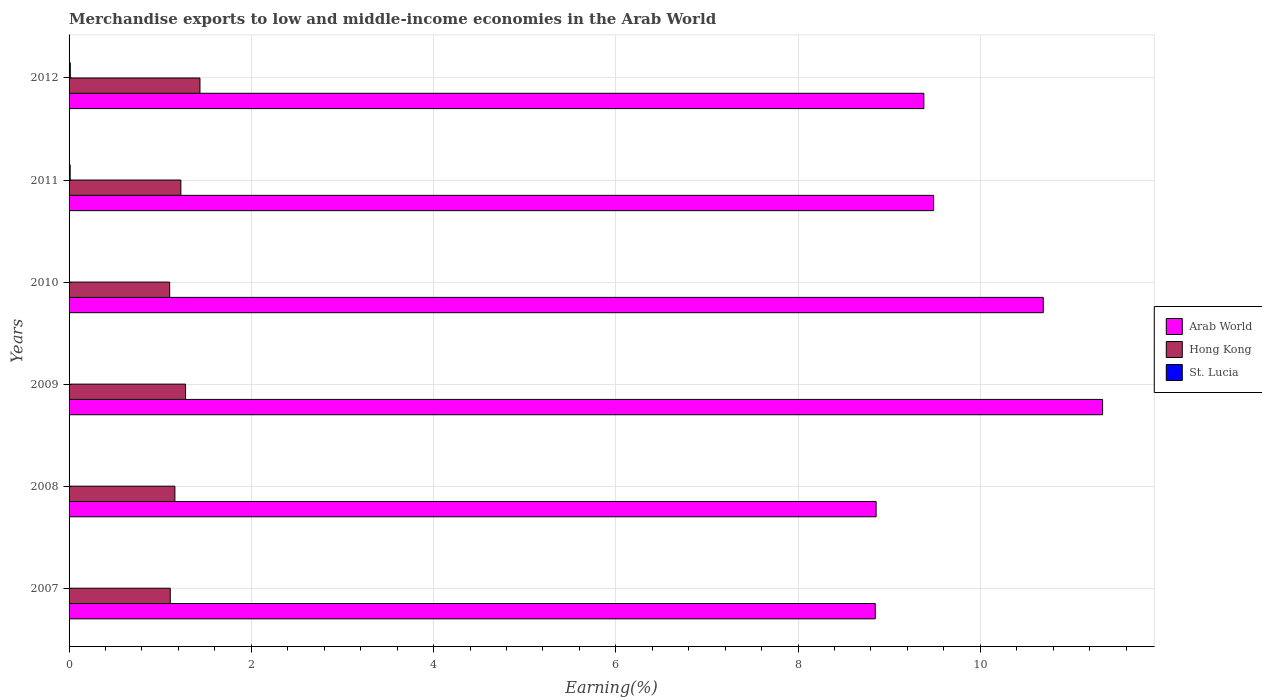Are the number of bars on each tick of the Y-axis equal?
Offer a terse response. Yes. What is the label of the 2nd group of bars from the top?
Offer a terse response. 2011. In how many cases, is the number of bars for a given year not equal to the number of legend labels?
Ensure brevity in your answer.  0. What is the percentage of amount earned from merchandise exports in St. Lucia in 2012?
Ensure brevity in your answer.  0.01. Across all years, what is the maximum percentage of amount earned from merchandise exports in Arab World?
Give a very brief answer. 11.34. Across all years, what is the minimum percentage of amount earned from merchandise exports in Hong Kong?
Ensure brevity in your answer.  1.1. In which year was the percentage of amount earned from merchandise exports in Arab World minimum?
Your response must be concise. 2007. What is the total percentage of amount earned from merchandise exports in St. Lucia in the graph?
Your answer should be compact. 0.03. What is the difference between the percentage of amount earned from merchandise exports in Hong Kong in 2008 and that in 2010?
Your response must be concise. 0.06. What is the difference between the percentage of amount earned from merchandise exports in St. Lucia in 2009 and the percentage of amount earned from merchandise exports in Arab World in 2012?
Keep it short and to the point. -9.38. What is the average percentage of amount earned from merchandise exports in Arab World per year?
Your answer should be very brief. 9.77. In the year 2008, what is the difference between the percentage of amount earned from merchandise exports in Hong Kong and percentage of amount earned from merchandise exports in St. Lucia?
Give a very brief answer. 1.16. In how many years, is the percentage of amount earned from merchandise exports in Arab World greater than 4 %?
Provide a succinct answer. 6. What is the ratio of the percentage of amount earned from merchandise exports in Hong Kong in 2009 to that in 2012?
Provide a succinct answer. 0.89. What is the difference between the highest and the second highest percentage of amount earned from merchandise exports in Hong Kong?
Give a very brief answer. 0.16. What is the difference between the highest and the lowest percentage of amount earned from merchandise exports in St. Lucia?
Give a very brief answer. 0.01. Is the sum of the percentage of amount earned from merchandise exports in Arab World in 2008 and 2012 greater than the maximum percentage of amount earned from merchandise exports in St. Lucia across all years?
Your answer should be compact. Yes. What does the 3rd bar from the top in 2011 represents?
Offer a very short reply. Arab World. What does the 2nd bar from the bottom in 2009 represents?
Ensure brevity in your answer.  Hong Kong. Is it the case that in every year, the sum of the percentage of amount earned from merchandise exports in Arab World and percentage of amount earned from merchandise exports in St. Lucia is greater than the percentage of amount earned from merchandise exports in Hong Kong?
Make the answer very short. Yes. Are all the bars in the graph horizontal?
Provide a succinct answer. Yes. How many years are there in the graph?
Your answer should be very brief. 6. How are the legend labels stacked?
Provide a short and direct response. Vertical. What is the title of the graph?
Your answer should be very brief. Merchandise exports to low and middle-income economies in the Arab World. Does "Vietnam" appear as one of the legend labels in the graph?
Make the answer very short. No. What is the label or title of the X-axis?
Provide a short and direct response. Earning(%). What is the Earning(%) of Arab World in 2007?
Your response must be concise. 8.85. What is the Earning(%) of Hong Kong in 2007?
Ensure brevity in your answer.  1.11. What is the Earning(%) of St. Lucia in 2007?
Your answer should be very brief. 0. What is the Earning(%) in Arab World in 2008?
Make the answer very short. 8.86. What is the Earning(%) of Hong Kong in 2008?
Your response must be concise. 1.16. What is the Earning(%) of St. Lucia in 2008?
Provide a short and direct response. 0. What is the Earning(%) of Arab World in 2009?
Your response must be concise. 11.34. What is the Earning(%) of Hong Kong in 2009?
Offer a terse response. 1.28. What is the Earning(%) in St. Lucia in 2009?
Make the answer very short. 0. What is the Earning(%) of Arab World in 2010?
Ensure brevity in your answer.  10.69. What is the Earning(%) of Hong Kong in 2010?
Your answer should be compact. 1.1. What is the Earning(%) in St. Lucia in 2010?
Keep it short and to the point. 0. What is the Earning(%) in Arab World in 2011?
Make the answer very short. 9.49. What is the Earning(%) of Hong Kong in 2011?
Offer a terse response. 1.23. What is the Earning(%) of St. Lucia in 2011?
Your answer should be very brief. 0.01. What is the Earning(%) of Arab World in 2012?
Keep it short and to the point. 9.38. What is the Earning(%) of Hong Kong in 2012?
Offer a terse response. 1.44. What is the Earning(%) in St. Lucia in 2012?
Provide a succinct answer. 0.01. Across all years, what is the maximum Earning(%) of Arab World?
Your answer should be very brief. 11.34. Across all years, what is the maximum Earning(%) of Hong Kong?
Make the answer very short. 1.44. Across all years, what is the maximum Earning(%) in St. Lucia?
Offer a very short reply. 0.01. Across all years, what is the minimum Earning(%) in Arab World?
Keep it short and to the point. 8.85. Across all years, what is the minimum Earning(%) of Hong Kong?
Ensure brevity in your answer.  1.1. Across all years, what is the minimum Earning(%) of St. Lucia?
Provide a short and direct response. 0. What is the total Earning(%) in Arab World in the graph?
Make the answer very short. 58.6. What is the total Earning(%) in Hong Kong in the graph?
Provide a succinct answer. 7.32. What is the total Earning(%) of St. Lucia in the graph?
Your answer should be very brief. 0.03. What is the difference between the Earning(%) in Arab World in 2007 and that in 2008?
Provide a succinct answer. -0.01. What is the difference between the Earning(%) in Hong Kong in 2007 and that in 2008?
Offer a very short reply. -0.05. What is the difference between the Earning(%) in St. Lucia in 2007 and that in 2008?
Your answer should be compact. -0. What is the difference between the Earning(%) of Arab World in 2007 and that in 2009?
Ensure brevity in your answer.  -2.49. What is the difference between the Earning(%) of Hong Kong in 2007 and that in 2009?
Offer a terse response. -0.17. What is the difference between the Earning(%) of Arab World in 2007 and that in 2010?
Provide a succinct answer. -1.84. What is the difference between the Earning(%) in Hong Kong in 2007 and that in 2010?
Your answer should be very brief. 0.01. What is the difference between the Earning(%) in St. Lucia in 2007 and that in 2010?
Make the answer very short. -0. What is the difference between the Earning(%) of Arab World in 2007 and that in 2011?
Ensure brevity in your answer.  -0.64. What is the difference between the Earning(%) of Hong Kong in 2007 and that in 2011?
Make the answer very short. -0.12. What is the difference between the Earning(%) of St. Lucia in 2007 and that in 2011?
Offer a very short reply. -0.01. What is the difference between the Earning(%) of Arab World in 2007 and that in 2012?
Give a very brief answer. -0.53. What is the difference between the Earning(%) of Hong Kong in 2007 and that in 2012?
Keep it short and to the point. -0.33. What is the difference between the Earning(%) of St. Lucia in 2007 and that in 2012?
Your response must be concise. -0.01. What is the difference between the Earning(%) in Arab World in 2008 and that in 2009?
Provide a short and direct response. -2.49. What is the difference between the Earning(%) of Hong Kong in 2008 and that in 2009?
Your response must be concise. -0.12. What is the difference between the Earning(%) in Arab World in 2008 and that in 2010?
Provide a succinct answer. -1.83. What is the difference between the Earning(%) of Hong Kong in 2008 and that in 2010?
Your answer should be very brief. 0.06. What is the difference between the Earning(%) of St. Lucia in 2008 and that in 2010?
Keep it short and to the point. -0. What is the difference between the Earning(%) in Arab World in 2008 and that in 2011?
Ensure brevity in your answer.  -0.63. What is the difference between the Earning(%) of Hong Kong in 2008 and that in 2011?
Your answer should be very brief. -0.07. What is the difference between the Earning(%) in St. Lucia in 2008 and that in 2011?
Your response must be concise. -0.01. What is the difference between the Earning(%) of Arab World in 2008 and that in 2012?
Keep it short and to the point. -0.52. What is the difference between the Earning(%) of Hong Kong in 2008 and that in 2012?
Your answer should be compact. -0.28. What is the difference between the Earning(%) of St. Lucia in 2008 and that in 2012?
Make the answer very short. -0.01. What is the difference between the Earning(%) in Arab World in 2009 and that in 2010?
Your answer should be very brief. 0.65. What is the difference between the Earning(%) of Hong Kong in 2009 and that in 2010?
Ensure brevity in your answer.  0.17. What is the difference between the Earning(%) in St. Lucia in 2009 and that in 2010?
Offer a terse response. -0. What is the difference between the Earning(%) of Arab World in 2009 and that in 2011?
Ensure brevity in your answer.  1.85. What is the difference between the Earning(%) in Hong Kong in 2009 and that in 2011?
Provide a succinct answer. 0.05. What is the difference between the Earning(%) of St. Lucia in 2009 and that in 2011?
Provide a short and direct response. -0.01. What is the difference between the Earning(%) in Arab World in 2009 and that in 2012?
Ensure brevity in your answer.  1.96. What is the difference between the Earning(%) of Hong Kong in 2009 and that in 2012?
Ensure brevity in your answer.  -0.16. What is the difference between the Earning(%) of St. Lucia in 2009 and that in 2012?
Your answer should be very brief. -0.01. What is the difference between the Earning(%) of Arab World in 2010 and that in 2011?
Offer a very short reply. 1.2. What is the difference between the Earning(%) in Hong Kong in 2010 and that in 2011?
Offer a very short reply. -0.12. What is the difference between the Earning(%) of St. Lucia in 2010 and that in 2011?
Keep it short and to the point. -0.01. What is the difference between the Earning(%) in Arab World in 2010 and that in 2012?
Ensure brevity in your answer.  1.31. What is the difference between the Earning(%) in Hong Kong in 2010 and that in 2012?
Ensure brevity in your answer.  -0.33. What is the difference between the Earning(%) in St. Lucia in 2010 and that in 2012?
Your answer should be very brief. -0.01. What is the difference between the Earning(%) of Arab World in 2011 and that in 2012?
Provide a short and direct response. 0.11. What is the difference between the Earning(%) in Hong Kong in 2011 and that in 2012?
Make the answer very short. -0.21. What is the difference between the Earning(%) of St. Lucia in 2011 and that in 2012?
Make the answer very short. -0. What is the difference between the Earning(%) of Arab World in 2007 and the Earning(%) of Hong Kong in 2008?
Your answer should be very brief. 7.69. What is the difference between the Earning(%) of Arab World in 2007 and the Earning(%) of St. Lucia in 2008?
Provide a short and direct response. 8.85. What is the difference between the Earning(%) of Hong Kong in 2007 and the Earning(%) of St. Lucia in 2008?
Ensure brevity in your answer.  1.11. What is the difference between the Earning(%) in Arab World in 2007 and the Earning(%) in Hong Kong in 2009?
Offer a very short reply. 7.57. What is the difference between the Earning(%) in Arab World in 2007 and the Earning(%) in St. Lucia in 2009?
Give a very brief answer. 8.85. What is the difference between the Earning(%) in Hong Kong in 2007 and the Earning(%) in St. Lucia in 2009?
Provide a succinct answer. 1.11. What is the difference between the Earning(%) of Arab World in 2007 and the Earning(%) of Hong Kong in 2010?
Your answer should be compact. 7.74. What is the difference between the Earning(%) in Arab World in 2007 and the Earning(%) in St. Lucia in 2010?
Offer a very short reply. 8.85. What is the difference between the Earning(%) in Hong Kong in 2007 and the Earning(%) in St. Lucia in 2010?
Offer a terse response. 1.11. What is the difference between the Earning(%) of Arab World in 2007 and the Earning(%) of Hong Kong in 2011?
Offer a very short reply. 7.62. What is the difference between the Earning(%) of Arab World in 2007 and the Earning(%) of St. Lucia in 2011?
Give a very brief answer. 8.84. What is the difference between the Earning(%) in Hong Kong in 2007 and the Earning(%) in St. Lucia in 2011?
Give a very brief answer. 1.1. What is the difference between the Earning(%) in Arab World in 2007 and the Earning(%) in Hong Kong in 2012?
Your response must be concise. 7.41. What is the difference between the Earning(%) in Arab World in 2007 and the Earning(%) in St. Lucia in 2012?
Your response must be concise. 8.83. What is the difference between the Earning(%) in Hong Kong in 2007 and the Earning(%) in St. Lucia in 2012?
Your response must be concise. 1.1. What is the difference between the Earning(%) of Arab World in 2008 and the Earning(%) of Hong Kong in 2009?
Provide a short and direct response. 7.58. What is the difference between the Earning(%) of Arab World in 2008 and the Earning(%) of St. Lucia in 2009?
Make the answer very short. 8.86. What is the difference between the Earning(%) in Hong Kong in 2008 and the Earning(%) in St. Lucia in 2009?
Provide a short and direct response. 1.16. What is the difference between the Earning(%) of Arab World in 2008 and the Earning(%) of Hong Kong in 2010?
Your answer should be compact. 7.75. What is the difference between the Earning(%) in Arab World in 2008 and the Earning(%) in St. Lucia in 2010?
Keep it short and to the point. 8.86. What is the difference between the Earning(%) in Hong Kong in 2008 and the Earning(%) in St. Lucia in 2010?
Give a very brief answer. 1.16. What is the difference between the Earning(%) of Arab World in 2008 and the Earning(%) of Hong Kong in 2011?
Ensure brevity in your answer.  7.63. What is the difference between the Earning(%) of Arab World in 2008 and the Earning(%) of St. Lucia in 2011?
Give a very brief answer. 8.84. What is the difference between the Earning(%) of Hong Kong in 2008 and the Earning(%) of St. Lucia in 2011?
Give a very brief answer. 1.15. What is the difference between the Earning(%) of Arab World in 2008 and the Earning(%) of Hong Kong in 2012?
Keep it short and to the point. 7.42. What is the difference between the Earning(%) of Arab World in 2008 and the Earning(%) of St. Lucia in 2012?
Your response must be concise. 8.84. What is the difference between the Earning(%) in Hong Kong in 2008 and the Earning(%) in St. Lucia in 2012?
Your answer should be compact. 1.15. What is the difference between the Earning(%) in Arab World in 2009 and the Earning(%) in Hong Kong in 2010?
Offer a very short reply. 10.24. What is the difference between the Earning(%) in Arab World in 2009 and the Earning(%) in St. Lucia in 2010?
Make the answer very short. 11.34. What is the difference between the Earning(%) of Hong Kong in 2009 and the Earning(%) of St. Lucia in 2010?
Provide a succinct answer. 1.28. What is the difference between the Earning(%) in Arab World in 2009 and the Earning(%) in Hong Kong in 2011?
Make the answer very short. 10.11. What is the difference between the Earning(%) of Arab World in 2009 and the Earning(%) of St. Lucia in 2011?
Your answer should be very brief. 11.33. What is the difference between the Earning(%) of Hong Kong in 2009 and the Earning(%) of St. Lucia in 2011?
Your answer should be very brief. 1.27. What is the difference between the Earning(%) in Arab World in 2009 and the Earning(%) in Hong Kong in 2012?
Make the answer very short. 9.91. What is the difference between the Earning(%) of Arab World in 2009 and the Earning(%) of St. Lucia in 2012?
Ensure brevity in your answer.  11.33. What is the difference between the Earning(%) in Hong Kong in 2009 and the Earning(%) in St. Lucia in 2012?
Provide a succinct answer. 1.26. What is the difference between the Earning(%) in Arab World in 2010 and the Earning(%) in Hong Kong in 2011?
Make the answer very short. 9.46. What is the difference between the Earning(%) of Arab World in 2010 and the Earning(%) of St. Lucia in 2011?
Provide a succinct answer. 10.68. What is the difference between the Earning(%) in Hong Kong in 2010 and the Earning(%) in St. Lucia in 2011?
Make the answer very short. 1.09. What is the difference between the Earning(%) of Arab World in 2010 and the Earning(%) of Hong Kong in 2012?
Your response must be concise. 9.25. What is the difference between the Earning(%) in Arab World in 2010 and the Earning(%) in St. Lucia in 2012?
Your answer should be very brief. 10.68. What is the difference between the Earning(%) of Hong Kong in 2010 and the Earning(%) of St. Lucia in 2012?
Ensure brevity in your answer.  1.09. What is the difference between the Earning(%) of Arab World in 2011 and the Earning(%) of Hong Kong in 2012?
Your response must be concise. 8.05. What is the difference between the Earning(%) of Arab World in 2011 and the Earning(%) of St. Lucia in 2012?
Give a very brief answer. 9.47. What is the difference between the Earning(%) of Hong Kong in 2011 and the Earning(%) of St. Lucia in 2012?
Provide a succinct answer. 1.21. What is the average Earning(%) in Arab World per year?
Your answer should be very brief. 9.77. What is the average Earning(%) of Hong Kong per year?
Your answer should be very brief. 1.22. What is the average Earning(%) in St. Lucia per year?
Your answer should be compact. 0. In the year 2007, what is the difference between the Earning(%) of Arab World and Earning(%) of Hong Kong?
Offer a very short reply. 7.74. In the year 2007, what is the difference between the Earning(%) in Arab World and Earning(%) in St. Lucia?
Provide a succinct answer. 8.85. In the year 2007, what is the difference between the Earning(%) in Hong Kong and Earning(%) in St. Lucia?
Keep it short and to the point. 1.11. In the year 2008, what is the difference between the Earning(%) of Arab World and Earning(%) of Hong Kong?
Give a very brief answer. 7.7. In the year 2008, what is the difference between the Earning(%) of Arab World and Earning(%) of St. Lucia?
Provide a succinct answer. 8.86. In the year 2008, what is the difference between the Earning(%) of Hong Kong and Earning(%) of St. Lucia?
Keep it short and to the point. 1.16. In the year 2009, what is the difference between the Earning(%) in Arab World and Earning(%) in Hong Kong?
Make the answer very short. 10.06. In the year 2009, what is the difference between the Earning(%) in Arab World and Earning(%) in St. Lucia?
Offer a terse response. 11.34. In the year 2009, what is the difference between the Earning(%) of Hong Kong and Earning(%) of St. Lucia?
Offer a terse response. 1.28. In the year 2010, what is the difference between the Earning(%) in Arab World and Earning(%) in Hong Kong?
Your answer should be compact. 9.59. In the year 2010, what is the difference between the Earning(%) of Arab World and Earning(%) of St. Lucia?
Give a very brief answer. 10.69. In the year 2010, what is the difference between the Earning(%) in Hong Kong and Earning(%) in St. Lucia?
Provide a succinct answer. 1.1. In the year 2011, what is the difference between the Earning(%) of Arab World and Earning(%) of Hong Kong?
Your response must be concise. 8.26. In the year 2011, what is the difference between the Earning(%) in Arab World and Earning(%) in St. Lucia?
Your answer should be very brief. 9.48. In the year 2011, what is the difference between the Earning(%) in Hong Kong and Earning(%) in St. Lucia?
Your answer should be compact. 1.21. In the year 2012, what is the difference between the Earning(%) of Arab World and Earning(%) of Hong Kong?
Offer a terse response. 7.94. In the year 2012, what is the difference between the Earning(%) of Arab World and Earning(%) of St. Lucia?
Offer a terse response. 9.37. In the year 2012, what is the difference between the Earning(%) in Hong Kong and Earning(%) in St. Lucia?
Provide a short and direct response. 1.42. What is the ratio of the Earning(%) of Arab World in 2007 to that in 2008?
Offer a terse response. 1. What is the ratio of the Earning(%) of Hong Kong in 2007 to that in 2008?
Your answer should be compact. 0.96. What is the ratio of the Earning(%) of St. Lucia in 2007 to that in 2008?
Offer a terse response. 0.75. What is the ratio of the Earning(%) of Arab World in 2007 to that in 2009?
Make the answer very short. 0.78. What is the ratio of the Earning(%) of Hong Kong in 2007 to that in 2009?
Provide a short and direct response. 0.87. What is the ratio of the Earning(%) in St. Lucia in 2007 to that in 2009?
Ensure brevity in your answer.  1.16. What is the ratio of the Earning(%) in Arab World in 2007 to that in 2010?
Make the answer very short. 0.83. What is the ratio of the Earning(%) of St. Lucia in 2007 to that in 2010?
Give a very brief answer. 0.46. What is the ratio of the Earning(%) of Arab World in 2007 to that in 2011?
Give a very brief answer. 0.93. What is the ratio of the Earning(%) in Hong Kong in 2007 to that in 2011?
Your answer should be very brief. 0.91. What is the ratio of the Earning(%) of St. Lucia in 2007 to that in 2011?
Your answer should be compact. 0.04. What is the ratio of the Earning(%) in Arab World in 2007 to that in 2012?
Offer a terse response. 0.94. What is the ratio of the Earning(%) of Hong Kong in 2007 to that in 2012?
Make the answer very short. 0.77. What is the ratio of the Earning(%) of St. Lucia in 2007 to that in 2012?
Make the answer very short. 0.03. What is the ratio of the Earning(%) of Arab World in 2008 to that in 2009?
Provide a succinct answer. 0.78. What is the ratio of the Earning(%) of Hong Kong in 2008 to that in 2009?
Keep it short and to the point. 0.91. What is the ratio of the Earning(%) of St. Lucia in 2008 to that in 2009?
Provide a succinct answer. 1.55. What is the ratio of the Earning(%) of Arab World in 2008 to that in 2010?
Make the answer very short. 0.83. What is the ratio of the Earning(%) of Hong Kong in 2008 to that in 2010?
Provide a short and direct response. 1.05. What is the ratio of the Earning(%) in St. Lucia in 2008 to that in 2010?
Offer a terse response. 0.62. What is the ratio of the Earning(%) in Arab World in 2008 to that in 2011?
Make the answer very short. 0.93. What is the ratio of the Earning(%) in Hong Kong in 2008 to that in 2011?
Ensure brevity in your answer.  0.95. What is the ratio of the Earning(%) in St. Lucia in 2008 to that in 2011?
Your answer should be very brief. 0.05. What is the ratio of the Earning(%) of Arab World in 2008 to that in 2012?
Your answer should be very brief. 0.94. What is the ratio of the Earning(%) of Hong Kong in 2008 to that in 2012?
Your answer should be compact. 0.81. What is the ratio of the Earning(%) in St. Lucia in 2008 to that in 2012?
Keep it short and to the point. 0.04. What is the ratio of the Earning(%) of Arab World in 2009 to that in 2010?
Your response must be concise. 1.06. What is the ratio of the Earning(%) in Hong Kong in 2009 to that in 2010?
Your answer should be very brief. 1.16. What is the ratio of the Earning(%) of St. Lucia in 2009 to that in 2010?
Offer a terse response. 0.4. What is the ratio of the Earning(%) of Arab World in 2009 to that in 2011?
Offer a very short reply. 1.2. What is the ratio of the Earning(%) in Hong Kong in 2009 to that in 2011?
Offer a terse response. 1.04. What is the ratio of the Earning(%) in St. Lucia in 2009 to that in 2011?
Your answer should be very brief. 0.03. What is the ratio of the Earning(%) of Arab World in 2009 to that in 2012?
Make the answer very short. 1.21. What is the ratio of the Earning(%) of Hong Kong in 2009 to that in 2012?
Make the answer very short. 0.89. What is the ratio of the Earning(%) of St. Lucia in 2009 to that in 2012?
Make the answer very short. 0.03. What is the ratio of the Earning(%) in Arab World in 2010 to that in 2011?
Offer a terse response. 1.13. What is the ratio of the Earning(%) of Hong Kong in 2010 to that in 2011?
Give a very brief answer. 0.9. What is the ratio of the Earning(%) in St. Lucia in 2010 to that in 2011?
Offer a terse response. 0.08. What is the ratio of the Earning(%) in Arab World in 2010 to that in 2012?
Provide a succinct answer. 1.14. What is the ratio of the Earning(%) in Hong Kong in 2010 to that in 2012?
Keep it short and to the point. 0.77. What is the ratio of the Earning(%) in St. Lucia in 2010 to that in 2012?
Provide a succinct answer. 0.07. What is the ratio of the Earning(%) in Arab World in 2011 to that in 2012?
Provide a short and direct response. 1.01. What is the ratio of the Earning(%) in Hong Kong in 2011 to that in 2012?
Make the answer very short. 0.85. What is the ratio of the Earning(%) in St. Lucia in 2011 to that in 2012?
Give a very brief answer. 0.89. What is the difference between the highest and the second highest Earning(%) of Arab World?
Your response must be concise. 0.65. What is the difference between the highest and the second highest Earning(%) of Hong Kong?
Provide a short and direct response. 0.16. What is the difference between the highest and the second highest Earning(%) in St. Lucia?
Keep it short and to the point. 0. What is the difference between the highest and the lowest Earning(%) of Arab World?
Your answer should be very brief. 2.49. What is the difference between the highest and the lowest Earning(%) of Hong Kong?
Offer a terse response. 0.33. What is the difference between the highest and the lowest Earning(%) of St. Lucia?
Keep it short and to the point. 0.01. 